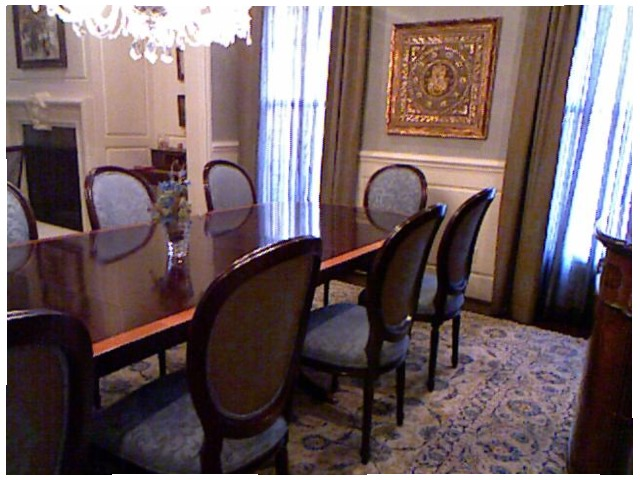<image>
Is there a chair under the table? Yes. The chair is positioned underneath the table, with the table above it in the vertical space. Where is the carpet in relation to the picture? Is it under the picture? No. The carpet is not positioned under the picture. The vertical relationship between these objects is different. Is there a painting on the table? No. The painting is not positioned on the table. They may be near each other, but the painting is not supported by or resting on top of the table. Where is the curtain in relation to the table? Is it above the table? No. The curtain is not positioned above the table. The vertical arrangement shows a different relationship. 